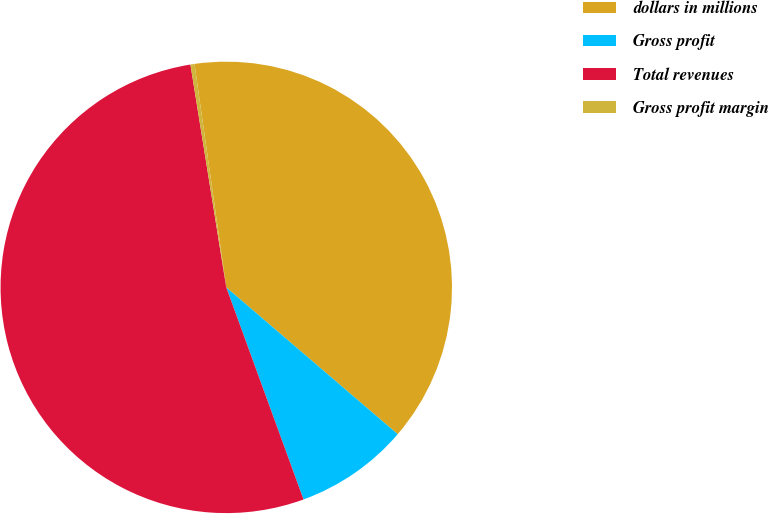Convert chart. <chart><loc_0><loc_0><loc_500><loc_500><pie_chart><fcel>dollars in millions<fcel>Gross profit<fcel>Total revenues<fcel>Gross profit margin<nl><fcel>38.52%<fcel>8.17%<fcel>53.02%<fcel>0.29%<nl></chart> 